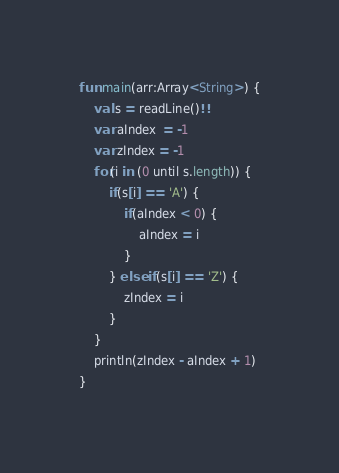Convert code to text. <code><loc_0><loc_0><loc_500><loc_500><_Kotlin_>fun main(arr:Array<String>) {
    val s = readLine()!!
    var aIndex  = -1
    var zIndex = -1
    for(i in (0 until s.length)) {
        if(s[i] == 'A') {
            if(aIndex < 0) {
                aIndex = i
            }
        } else if(s[i] == 'Z') {
            zIndex = i
        }
    }
    println(zIndex - aIndex + 1)
}</code> 